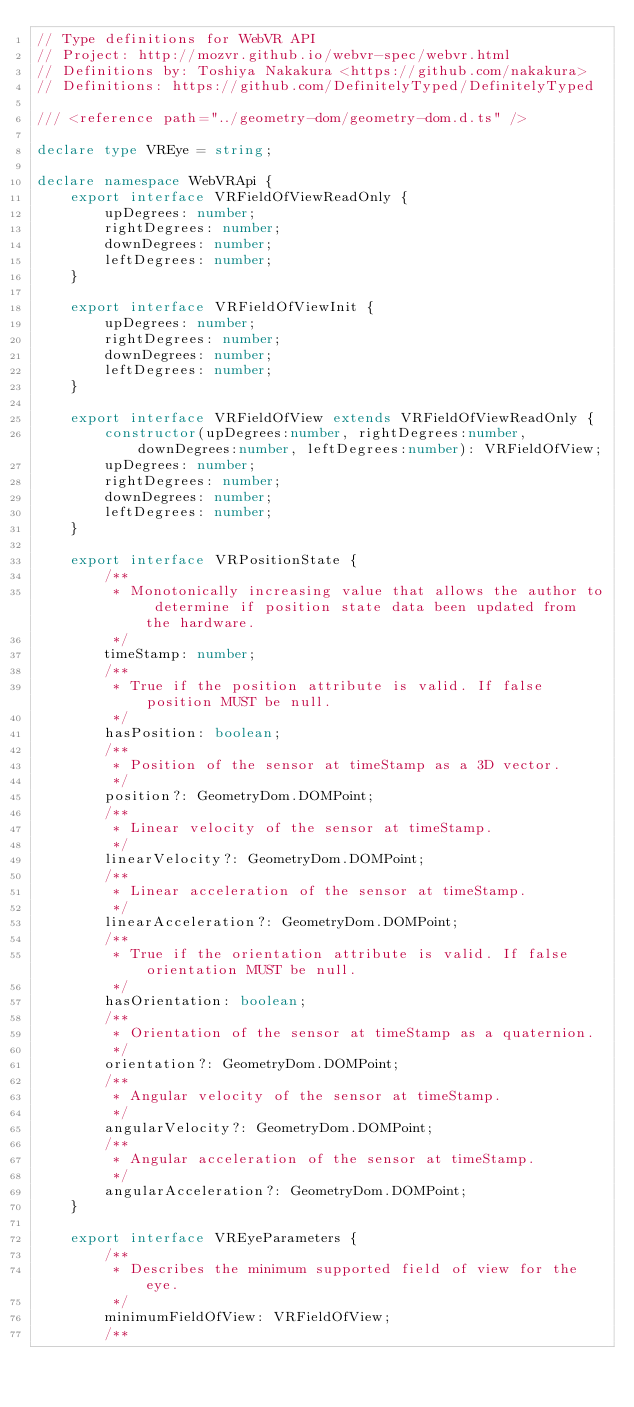<code> <loc_0><loc_0><loc_500><loc_500><_TypeScript_>// Type definitions for WebVR API
// Project: http://mozvr.github.io/webvr-spec/webvr.html
// Definitions by: Toshiya Nakakura <https://github.com/nakakura>
// Definitions: https://github.com/DefinitelyTyped/DefinitelyTyped

/// <reference path="../geometry-dom/geometry-dom.d.ts" />

declare type VREye = string;

declare namespace WebVRApi {
    export interface VRFieldOfViewReadOnly {
        upDegrees: number;
        rightDegrees: number;
        downDegrees: number;
        leftDegrees: number;
    }

    export interface VRFieldOfViewInit {
        upDegrees: number;
        rightDegrees: number;
        downDegrees: number;
        leftDegrees: number;
    }

    export interface VRFieldOfView extends VRFieldOfViewReadOnly {
        constructor(upDegrees:number, rightDegrees:number, downDegrees:number, leftDegrees:number): VRFieldOfView;
        upDegrees: number;
        rightDegrees: number;
        downDegrees: number;
        leftDegrees: number;
    }

    export interface VRPositionState {
        /**
         * Monotonically increasing value that allows the author to determine if position state data been updated from the hardware.
         */
        timeStamp: number;
        /**
         * True if the position attribute is valid. If false position MUST be null.
         */
        hasPosition: boolean;
        /**
         * Position of the sensor at timeStamp as a 3D vector.
         */
        position?: GeometryDom.DOMPoint;
        /**
         * Linear velocity of the sensor at timeStamp.
         */
        linearVelocity?: GeometryDom.DOMPoint;
        /**
         * Linear acceleration of the sensor at timeStamp.
         */
        linearAcceleration?: GeometryDom.DOMPoint;
        /**
         * True if the orientation attribute is valid. If false orientation MUST be null.
         */
        hasOrientation: boolean;
        /**
         * Orientation of the sensor at timeStamp as a quaternion.
         */
        orientation?: GeometryDom.DOMPoint;
        /**
         * Angular velocity of the sensor at timeStamp.
         */
        angularVelocity?: GeometryDom.DOMPoint;
        /**
         * Angular acceleration of the sensor at timeStamp.
         */
        angularAcceleration?: GeometryDom.DOMPoint;
    }

    export interface VREyeParameters {
        /**
         * Describes the minimum supported field of view for the eye.
         */
        minimumFieldOfView: VRFieldOfView;
        /**</code> 